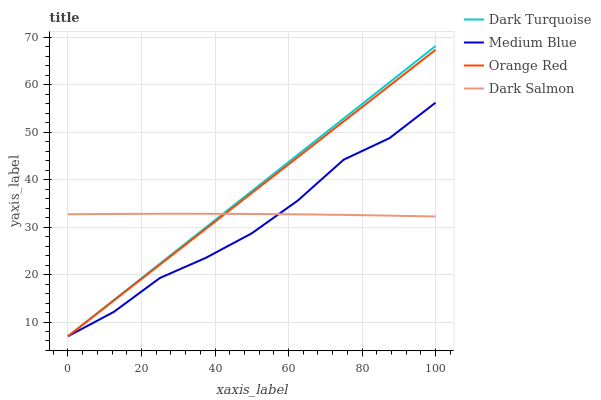Does Medium Blue have the minimum area under the curve?
Answer yes or no. Yes. Does Dark Turquoise have the maximum area under the curve?
Answer yes or no. Yes. Does Orange Red have the minimum area under the curve?
Answer yes or no. No. Does Orange Red have the maximum area under the curve?
Answer yes or no. No. Is Orange Red the smoothest?
Answer yes or no. Yes. Is Medium Blue the roughest?
Answer yes or no. Yes. Is Medium Blue the smoothest?
Answer yes or no. No. Is Orange Red the roughest?
Answer yes or no. No. Does Dark Turquoise have the lowest value?
Answer yes or no. Yes. Does Dark Salmon have the lowest value?
Answer yes or no. No. Does Dark Turquoise have the highest value?
Answer yes or no. Yes. Does Medium Blue have the highest value?
Answer yes or no. No. Does Medium Blue intersect Orange Red?
Answer yes or no. Yes. Is Medium Blue less than Orange Red?
Answer yes or no. No. Is Medium Blue greater than Orange Red?
Answer yes or no. No. 